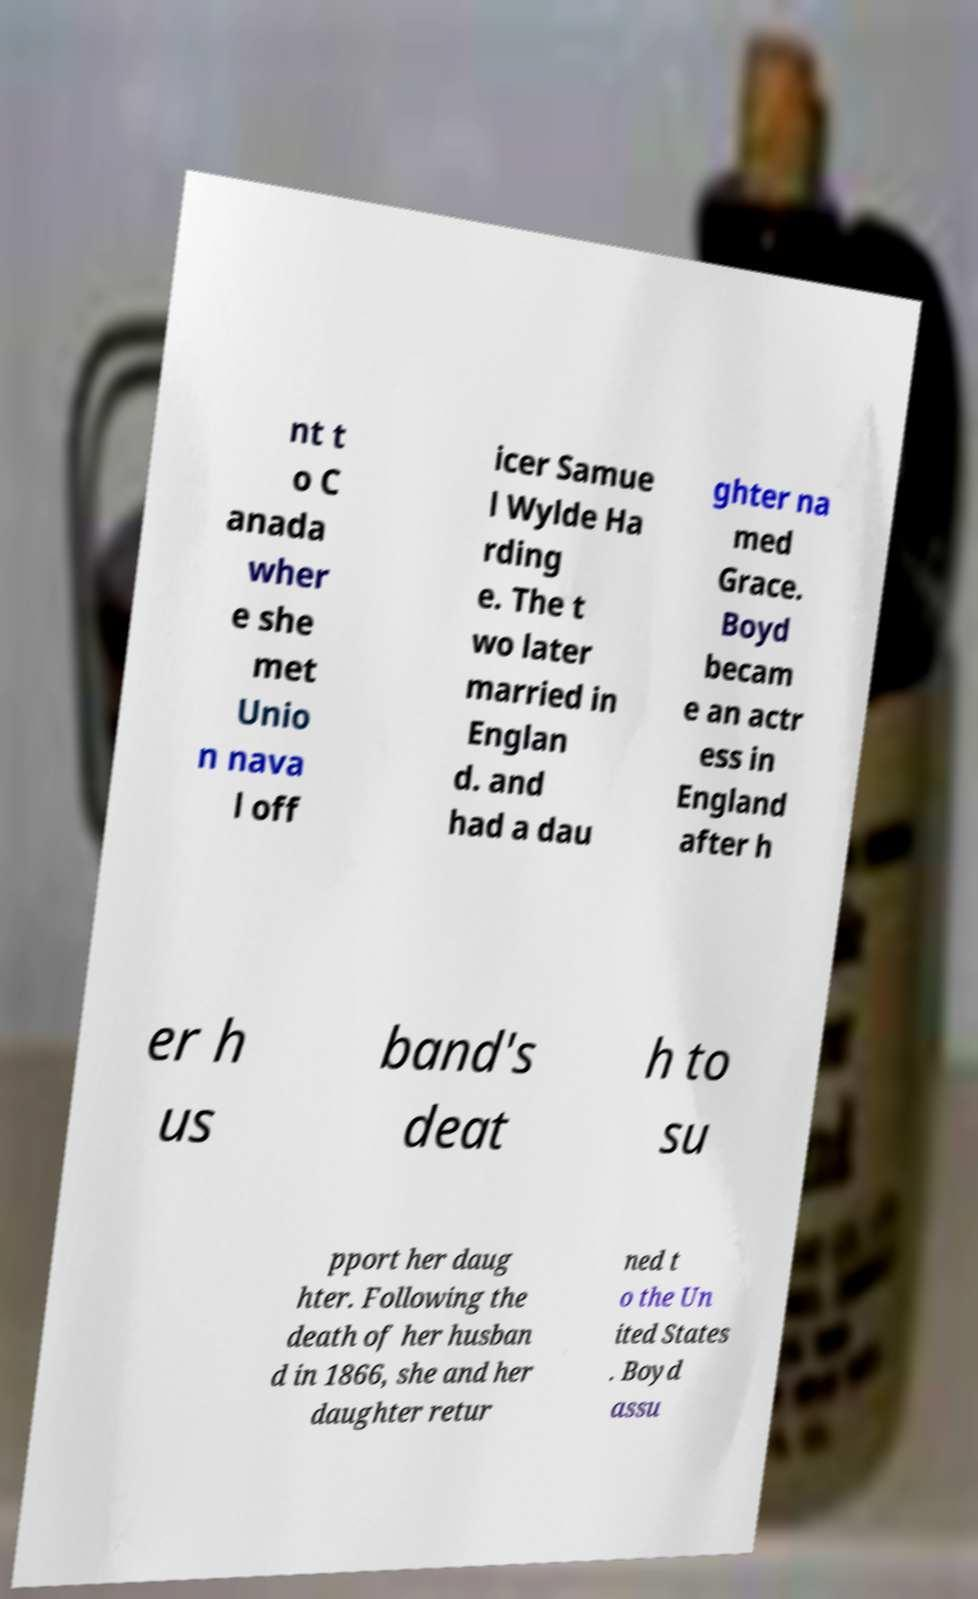Can you read and provide the text displayed in the image?This photo seems to have some interesting text. Can you extract and type it out for me? nt t o C anada wher e she met Unio n nava l off icer Samue l Wylde Ha rding e. The t wo later married in Englan d. and had a dau ghter na med Grace. Boyd becam e an actr ess in England after h er h us band's deat h to su pport her daug hter. Following the death of her husban d in 1866, she and her daughter retur ned t o the Un ited States . Boyd assu 